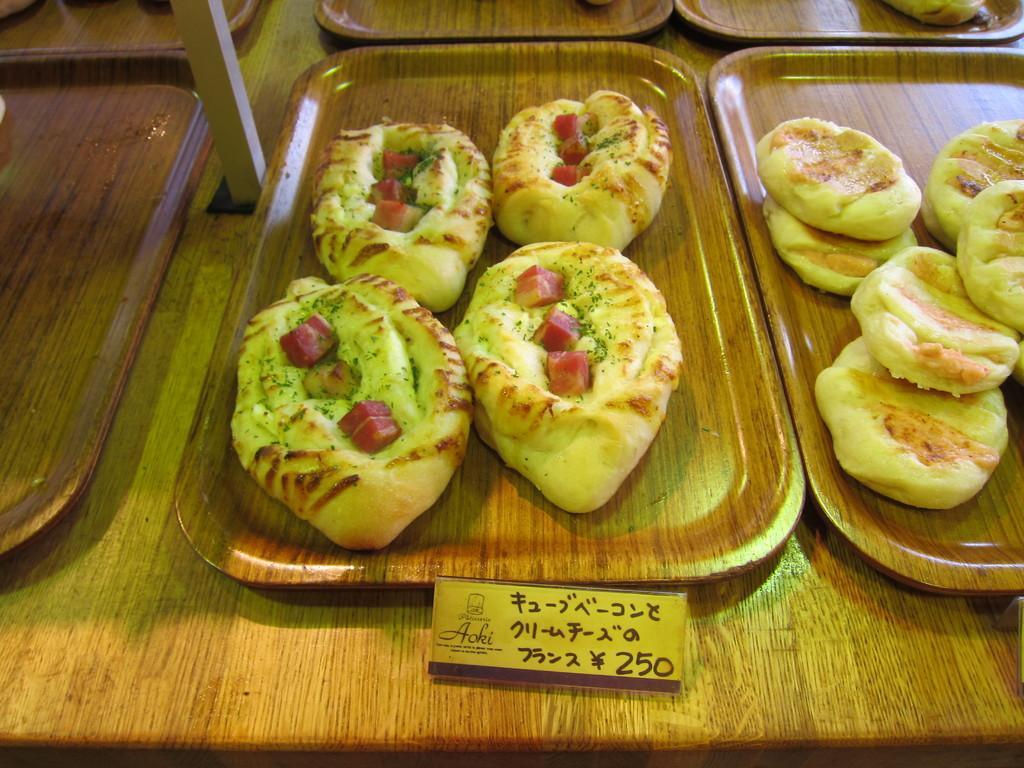Could you give a brief overview of what you see in this image? In this image, we can see planets on the table contains some food. There is a price strip at the bottom of the image. 